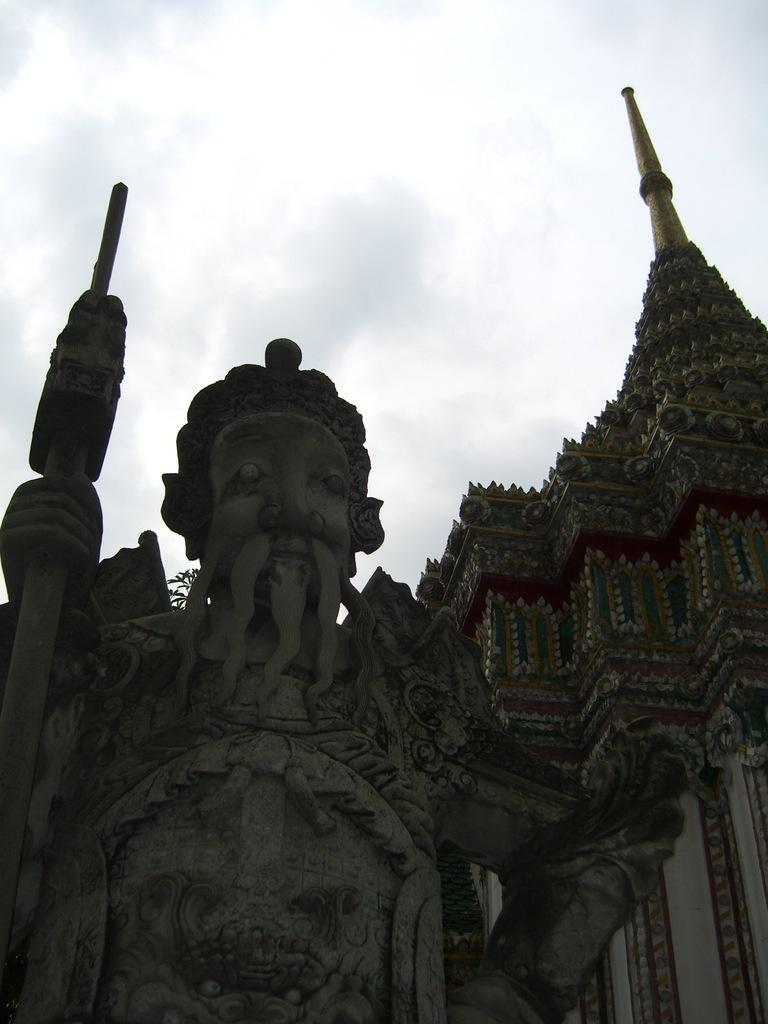What is the main subject of the image? There is a sculpture in the image. What can be seen in the background of the image? There is a building and the sky visible in the background of the image. What type of plants can be seen growing on the branch in the image? There is no branch or plants present in the image; it features a sculpture and a background with a building and the sky. 